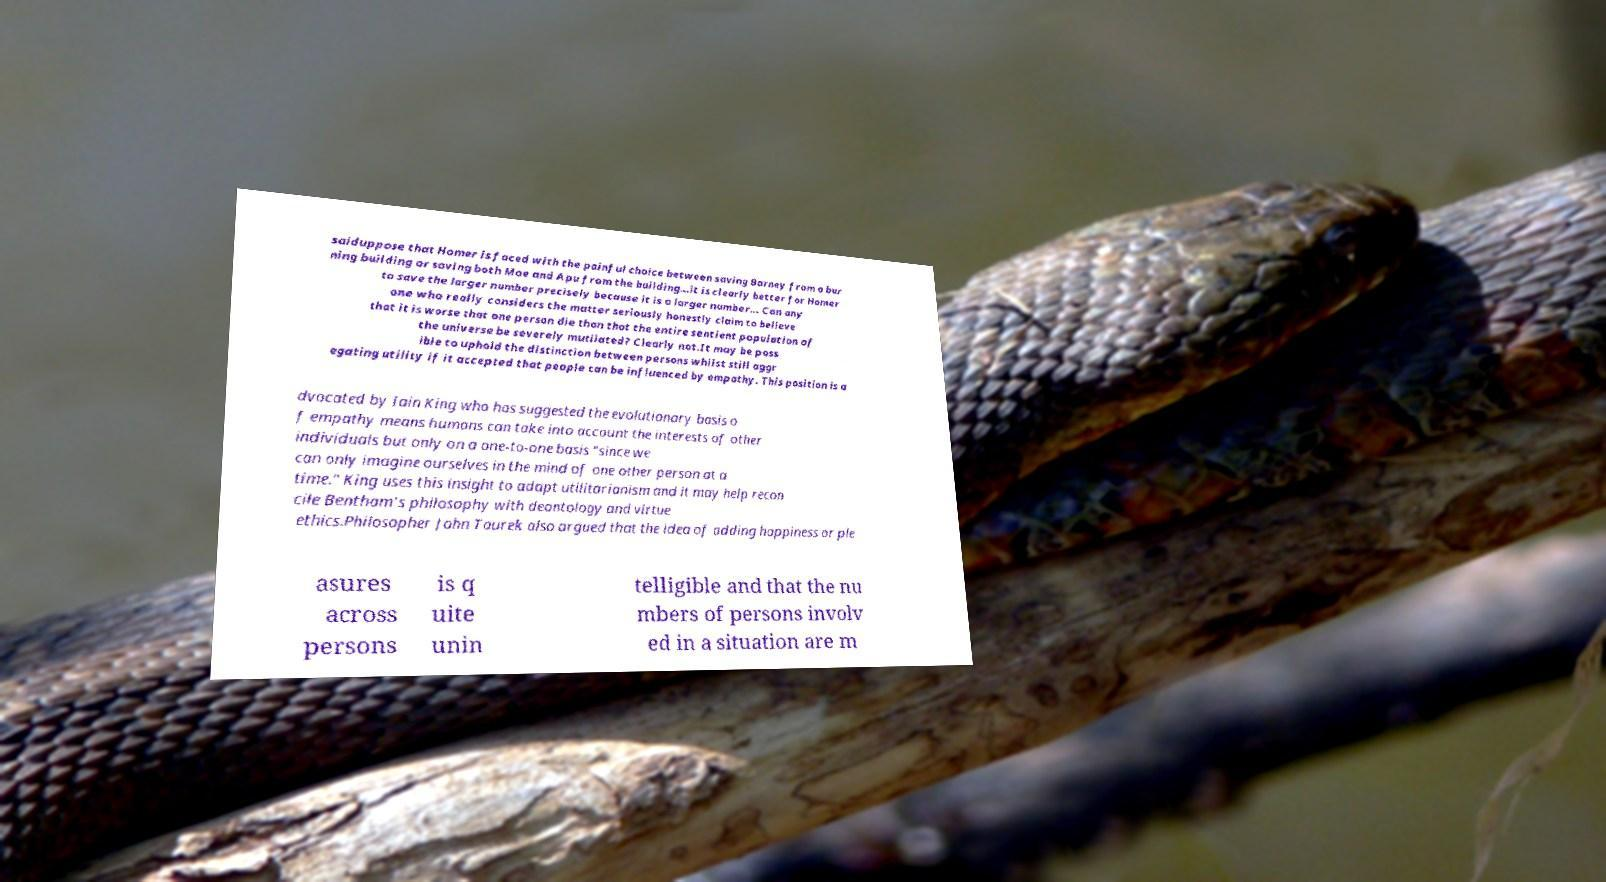Can you accurately transcribe the text from the provided image for me? saiduppose that Homer is faced with the painful choice between saving Barney from a bur ning building or saving both Moe and Apu from the building...it is clearly better for Homer to save the larger number precisely because it is a larger number... Can any one who really considers the matter seriously honestly claim to believe that it is worse that one person die than that the entire sentient population of the universe be severely mutilated? Clearly not.It may be poss ible to uphold the distinction between persons whilst still aggr egating utility if it accepted that people can be influenced by empathy. This position is a dvocated by Iain King who has suggested the evolutionary basis o f empathy means humans can take into account the interests of other individuals but only on a one-to-one basis "since we can only imagine ourselves in the mind of one other person at a time." King uses this insight to adapt utilitarianism and it may help recon cile Bentham's philosophy with deontology and virtue ethics.Philosopher John Taurek also argued that the idea of adding happiness or ple asures across persons is q uite unin telligible and that the nu mbers of persons involv ed in a situation are m 